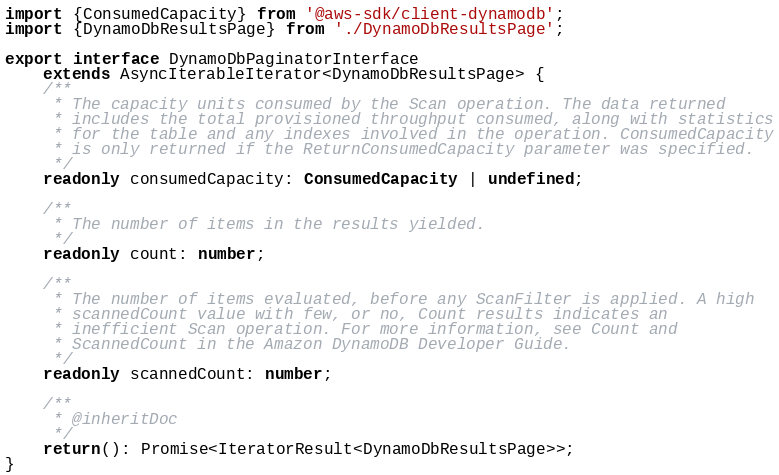Convert code to text. <code><loc_0><loc_0><loc_500><loc_500><_TypeScript_>import {ConsumedCapacity} from '@aws-sdk/client-dynamodb';
import {DynamoDbResultsPage} from './DynamoDbResultsPage';

export interface DynamoDbPaginatorInterface
	extends AsyncIterableIterator<DynamoDbResultsPage> {
	/**
     * The capacity units consumed by the Scan operation. The data returned
     * includes the total provisioned throughput consumed, along with statistics
     * for the table and any indexes involved in the operation. ConsumedCapacity
     * is only returned if the ReturnConsumedCapacity parameter was specified.
     */
	readonly consumedCapacity: ConsumedCapacity | undefined;

	/**
     * The number of items in the results yielded.
     */
	readonly count: number;

	/**
     * The number of items evaluated, before any ScanFilter is applied. A high
     * scannedCount value with few, or no, Count results indicates an
     * inefficient Scan operation. For more information, see Count and
     * ScannedCount in the Amazon DynamoDB Developer Guide.
     */
	readonly scannedCount: number;

	/**
     * @inheritDoc
     */
	return(): Promise<IteratorResult<DynamoDbResultsPage>>;
}
</code> 